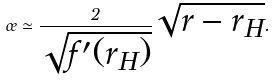<formula> <loc_0><loc_0><loc_500><loc_500>\sigma \simeq \frac { 2 } { \sqrt { f ^ { \prime } ( r _ { H } ) } } \sqrt { r - r _ { H } } .</formula> 